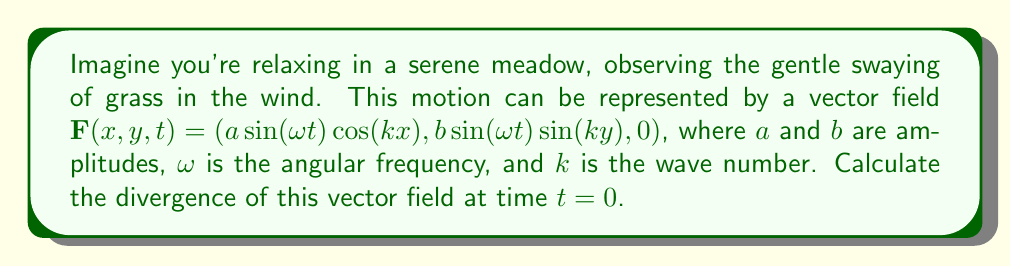Can you answer this question? Let's approach this step-by-step:

1) The divergence of a vector field $\mathbf{F}(x,y,z) = (F_x, F_y, F_z)$ in 3D is given by:

   $$\nabla \cdot \mathbf{F} = \frac{\partial F_x}{\partial x} + \frac{\partial F_y}{\partial y} + \frac{\partial F_z}{\partial z}$$

2) In our case, we have:
   $F_x = a\sin(\omega t)\cos(kx)$
   $F_y = b\sin(\omega t)\sin(ky)$
   $F_z = 0$

3) We need to calculate:
   $$\frac{\partial F_x}{\partial x} = -ak\sin(\omega t)\sin(kx)$$
   $$\frac{\partial F_y}{\partial y} = bk\sin(\omega t)\cos(ky)$$
   $$\frac{\partial F_z}{\partial z} = 0$$

4) The divergence is the sum of these partial derivatives:
   $$\nabla \cdot \mathbf{F} = -ak\sin(\omega t)\sin(kx) + bk\sin(\omega t)\cos(ky) + 0$$

5) At time $t=0$, $\sin(\omega t) = 0$, so:
   $$\nabla \cdot \mathbf{F}|_{t=0} = 0$$

This result indicates that at $t=0$, the vector field is incompressible, meaning the grass blades are not converging or diverging at this instant.
Answer: $0$ 